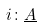<formula> <loc_0><loc_0><loc_500><loc_500>i \colon \underline { A }</formula> 